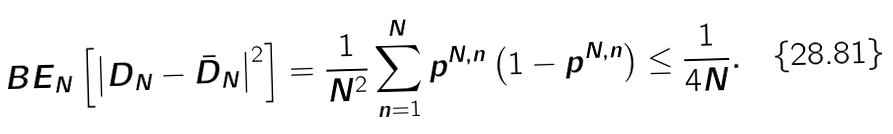Convert formula to latex. <formula><loc_0><loc_0><loc_500><loc_500>\ B E _ { N } \left [ \left | D _ { N } - \bar { D } _ { N } \right | ^ { 2 } \right ] = \frac { 1 } { N ^ { 2 } } \sum _ { n = 1 } ^ { N } p ^ { N , n } \left ( 1 - p ^ { N , n } \right ) \leq \frac { 1 } { 4 N } .</formula> 